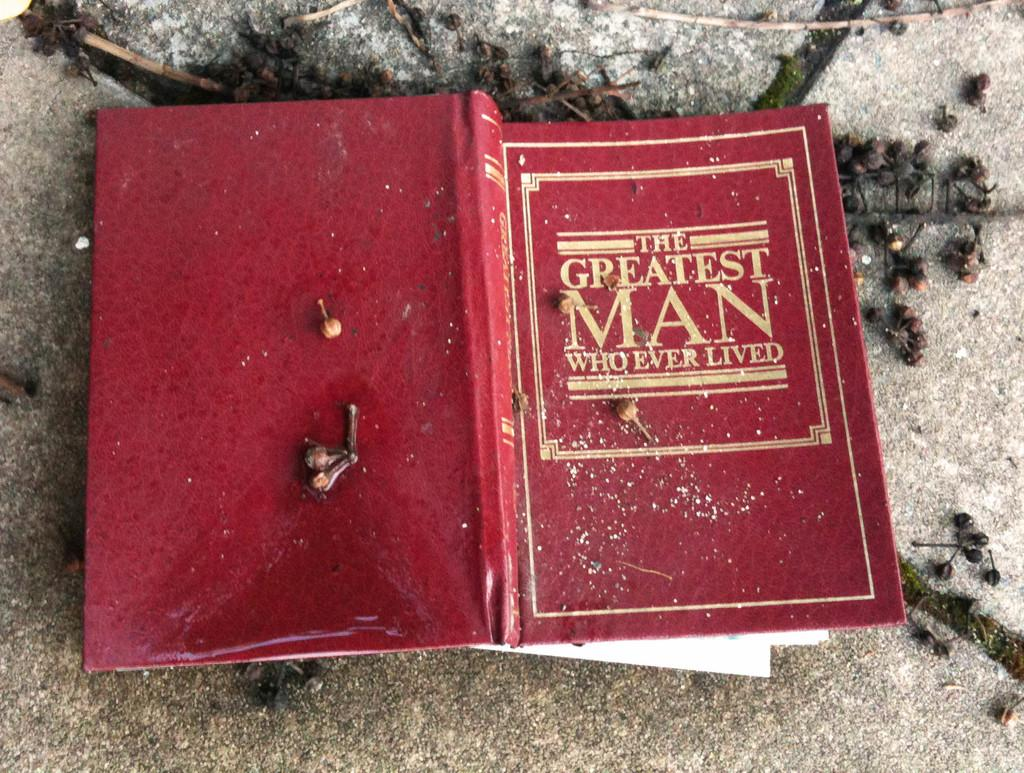Provide a one-sentence caption for the provided image. The greatest man who ever lived chapter book. 